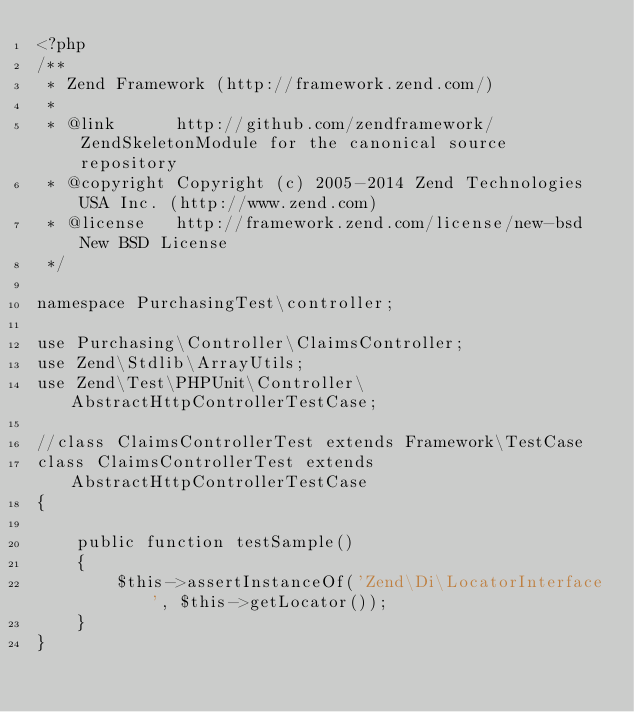<code> <loc_0><loc_0><loc_500><loc_500><_PHP_><?php
/**
 * Zend Framework (http://framework.zend.com/)
 *
 * @link      http://github.com/zendframework/ZendSkeletonModule for the canonical source repository
 * @copyright Copyright (c) 2005-2014 Zend Technologies USA Inc. (http://www.zend.com)
 * @license   http://framework.zend.com/license/new-bsd New BSD License
 */

namespace PurchasingTest\controller;

use Purchasing\Controller\ClaimsController;
use Zend\Stdlib\ArrayUtils;
use Zend\Test\PHPUnit\Controller\AbstractHttpControllerTestCase;

//class ClaimsControllerTest extends Framework\TestCase
class ClaimsControllerTest extends AbstractHttpControllerTestCase
{

    public function testSample()
    {
        $this->assertInstanceOf('Zend\Di\LocatorInterface', $this->getLocator());
    }
}
</code> 